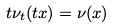<formula> <loc_0><loc_0><loc_500><loc_500>t \nu _ { t } ( t x ) = \nu ( x )</formula> 